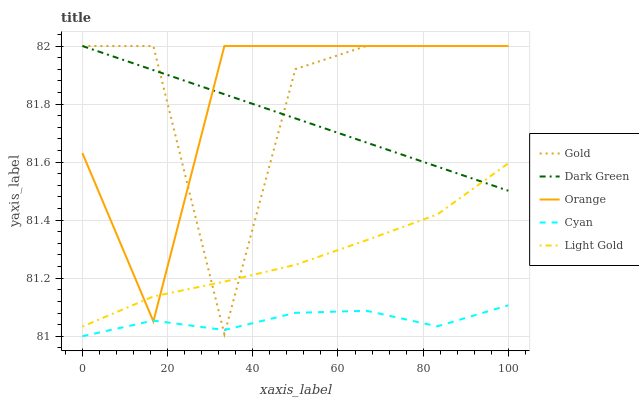Does Cyan have the minimum area under the curve?
Answer yes or no. Yes. Does Gold have the maximum area under the curve?
Answer yes or no. Yes. Does Light Gold have the minimum area under the curve?
Answer yes or no. No. Does Light Gold have the maximum area under the curve?
Answer yes or no. No. Is Dark Green the smoothest?
Answer yes or no. Yes. Is Gold the roughest?
Answer yes or no. Yes. Is Cyan the smoothest?
Answer yes or no. No. Is Cyan the roughest?
Answer yes or no. No. Does Cyan have the lowest value?
Answer yes or no. Yes. Does Light Gold have the lowest value?
Answer yes or no. No. Does Dark Green have the highest value?
Answer yes or no. Yes. Does Light Gold have the highest value?
Answer yes or no. No. Is Cyan less than Light Gold?
Answer yes or no. Yes. Is Light Gold greater than Cyan?
Answer yes or no. Yes. Does Gold intersect Dark Green?
Answer yes or no. Yes. Is Gold less than Dark Green?
Answer yes or no. No. Is Gold greater than Dark Green?
Answer yes or no. No. Does Cyan intersect Light Gold?
Answer yes or no. No. 